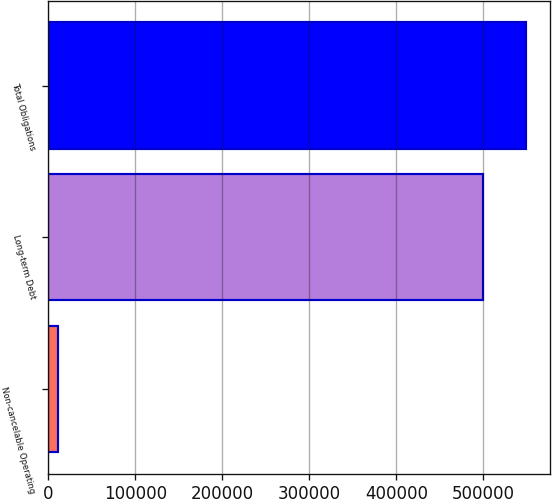Convert chart. <chart><loc_0><loc_0><loc_500><loc_500><bar_chart><fcel>Non-cancelable Operating<fcel>Long-term Debt<fcel>Total Obligations<nl><fcel>11645<fcel>499155<fcel>549070<nl></chart> 